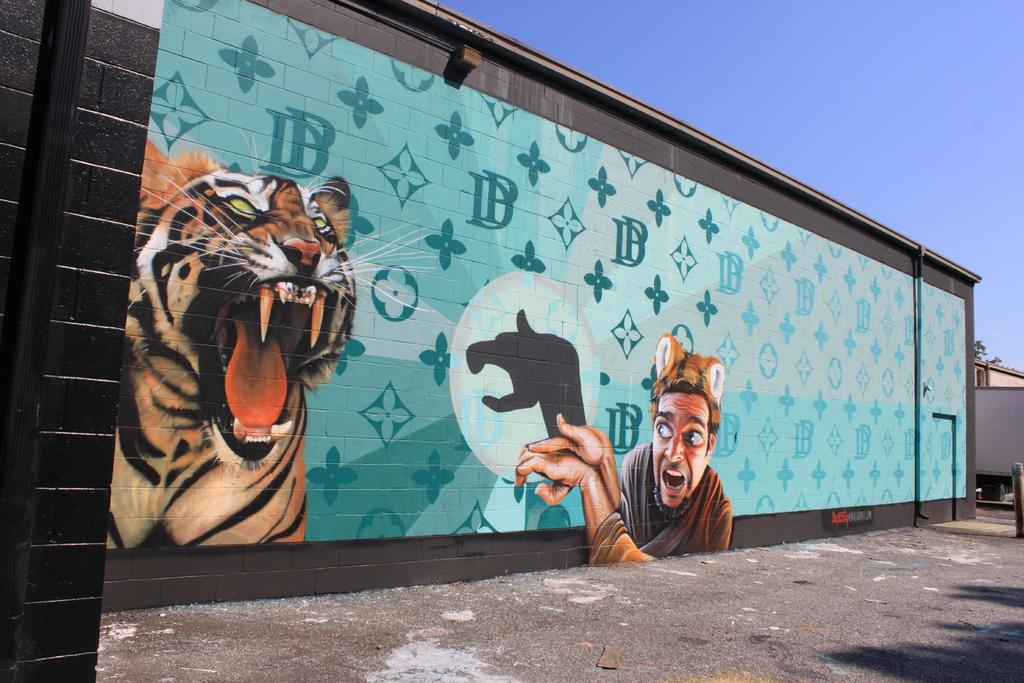What is the main feature of the image? There is a road in the image. What else can be seen in the image besides the road? There is a wall with a painting in the image. What is the subject of the painting? The painting depicts a man and a tiger. Are there any other objects or structures visible in the image? Yes, there are pipes in the image. What can be seen in the background of the image? The sky is visible in the background of the image. What type of apparel is the tiger wearing in the painting? The tiger is not wearing any apparel in the painting, as it is a wild animal and not a human. 